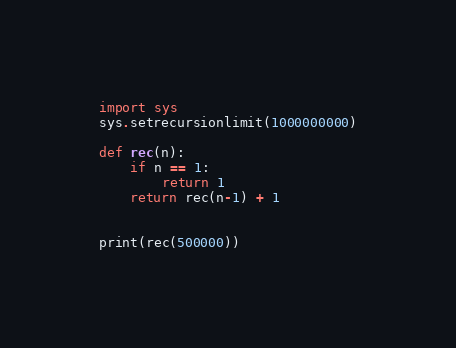Convert code to text. <code><loc_0><loc_0><loc_500><loc_500><_Python_>import sys
sys.setrecursionlimit(1000000000)

def rec(n):
    if n == 1:
        return 1
    return rec(n-1) + 1


print(rec(500000))
</code> 